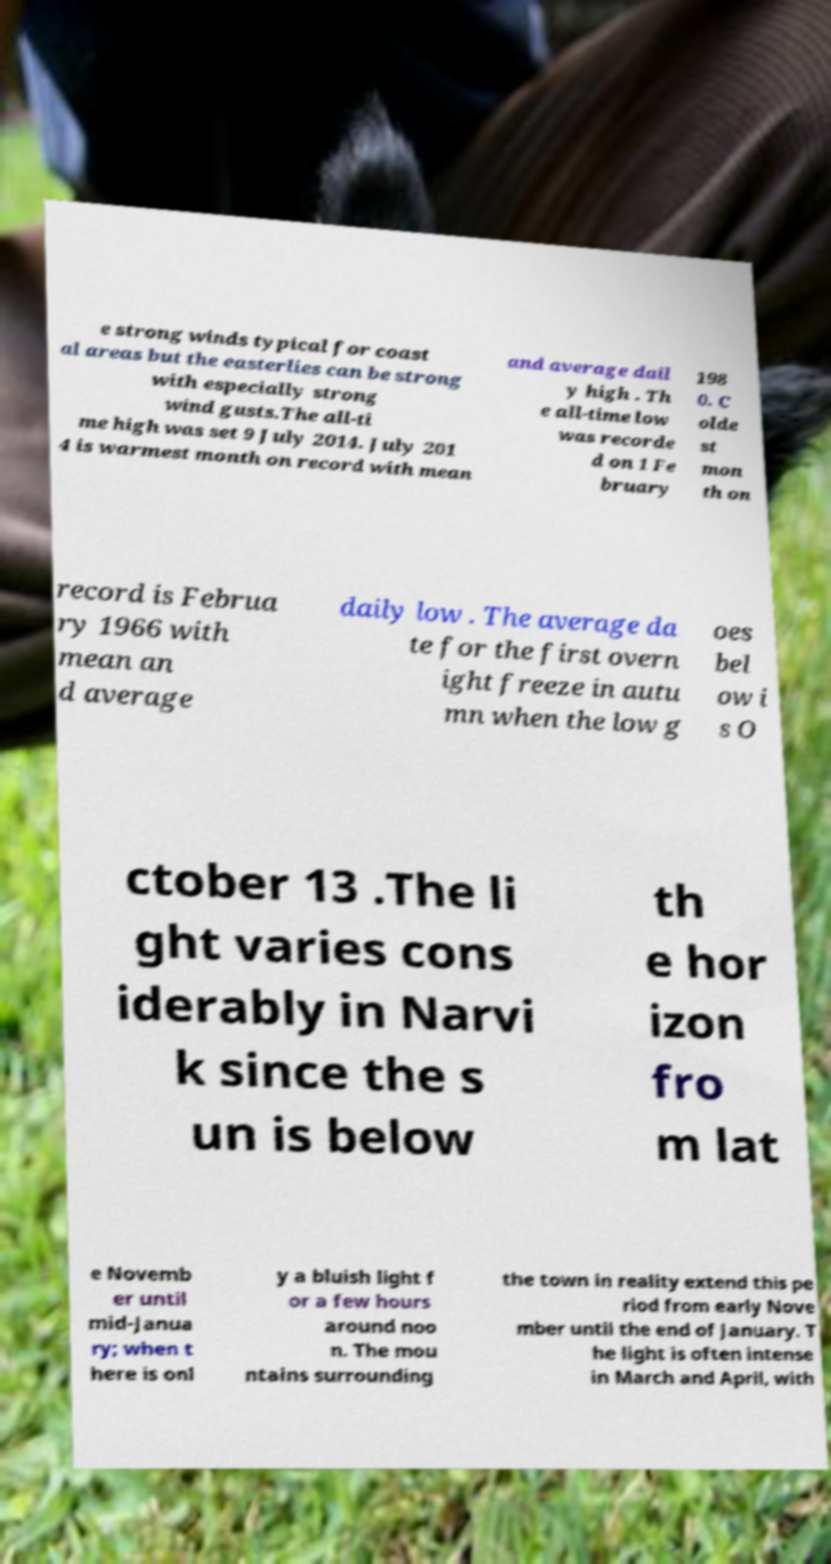Could you assist in decoding the text presented in this image and type it out clearly? e strong winds typical for coast al areas but the easterlies can be strong with especially strong wind gusts.The all-ti me high was set 9 July 2014. July 201 4 is warmest month on record with mean and average dail y high . Th e all-time low was recorde d on 1 Fe bruary 198 0. C olde st mon th on record is Februa ry 1966 with mean an d average daily low . The average da te for the first overn ight freeze in autu mn when the low g oes bel ow i s O ctober 13 .The li ght varies cons iderably in Narvi k since the s un is below th e hor izon fro m lat e Novemb er until mid-Janua ry; when t here is onl y a bluish light f or a few hours around noo n. The mou ntains surrounding the town in reality extend this pe riod from early Nove mber until the end of January. T he light is often intense in March and April, with 